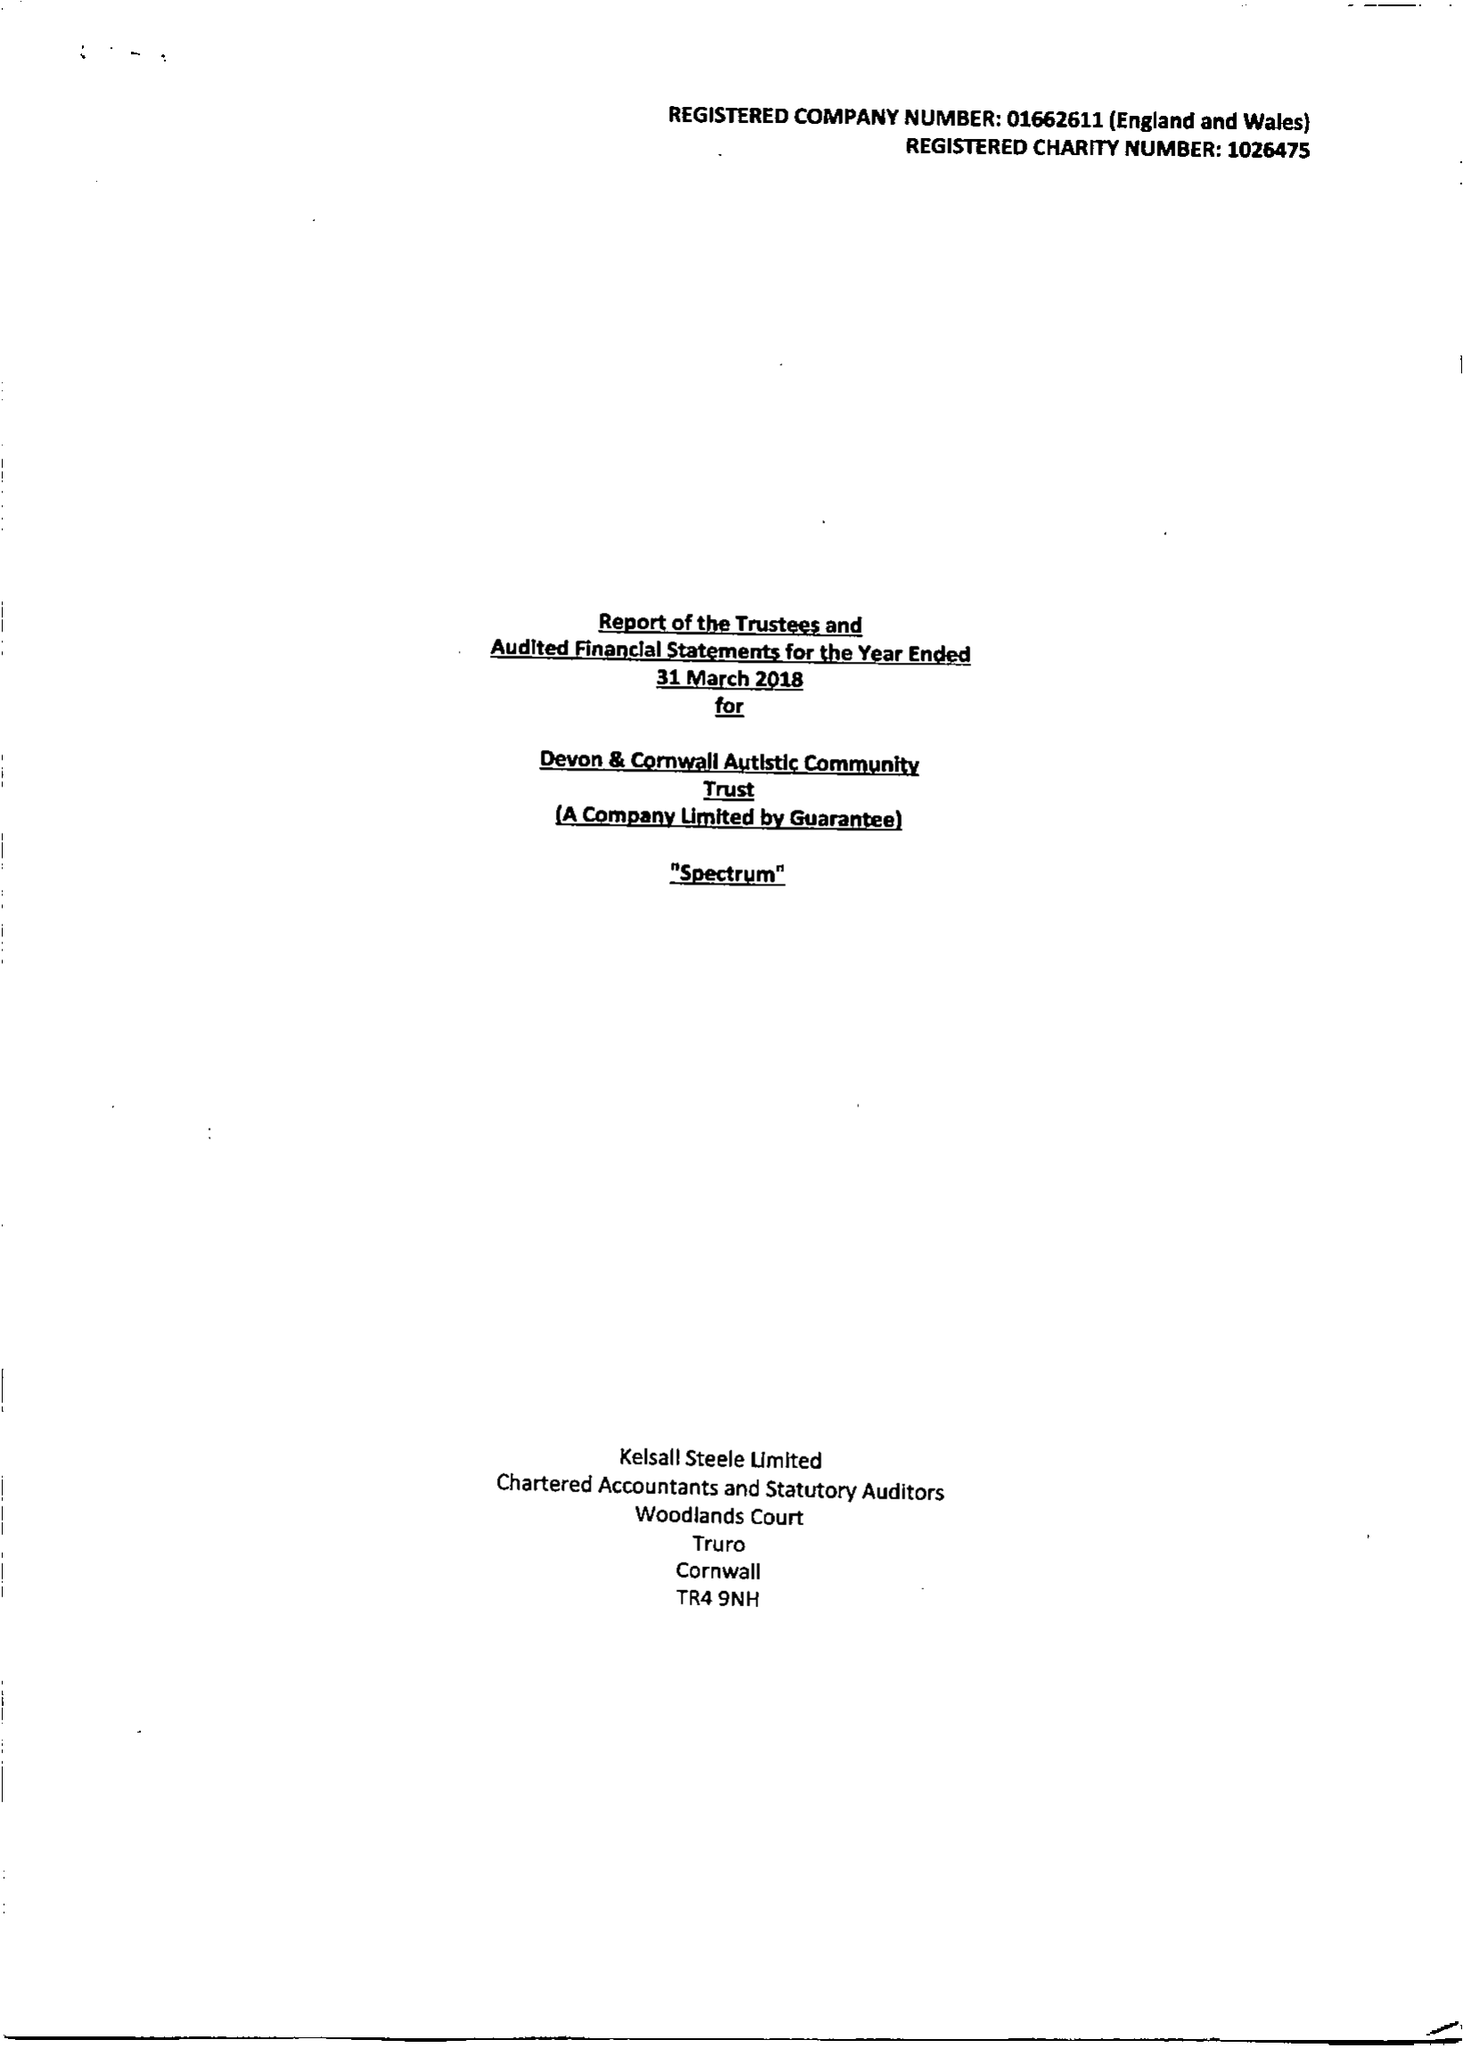What is the value for the address__street_line?
Answer the question using a single word or phrase. None 